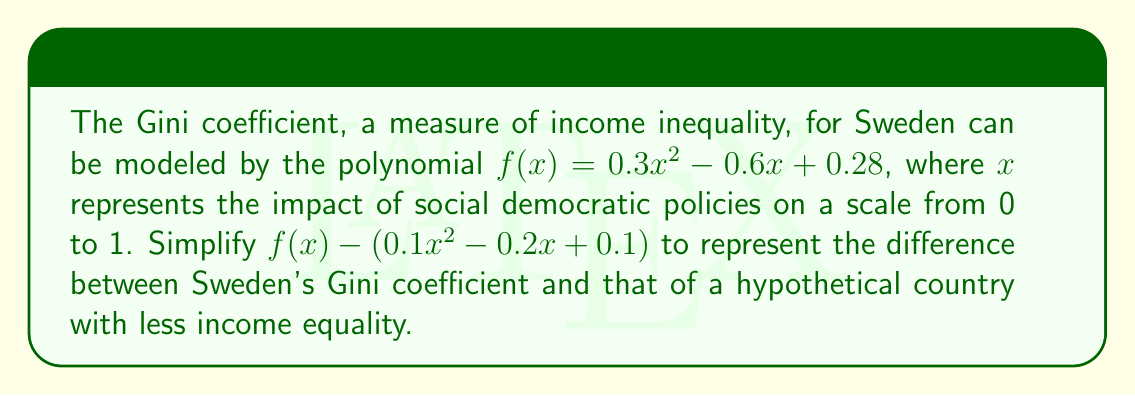What is the answer to this math problem? To simplify the expression, we need to subtract the given polynomial from $f(x)$:

1) First, let's write out the expression:
   $$(0.3x^2 - 0.6x + 0.28) - (0.1x^2 - 0.2x + 0.1)$$

2) Now, we'll subtract the terms of the second polynomial from the first:
   
   For $x^2$ terms: $0.3x^2 - 0.1x^2 = 0.2x^2$
   
   For $x$ terms: $-0.6x - (-0.2x) = -0.6x + 0.2x = -0.4x$
   
   For constant terms: $0.28 - 0.1 = 0.18$

3) Combining these results:
   $$0.2x^2 - 0.4x + 0.18$$

This simplified polynomial represents the difference in Gini coefficients between Sweden and the hypothetical country with less income equality, as a function of social democratic policy impact.
Answer: $0.2x^2 - 0.4x + 0.18$ 